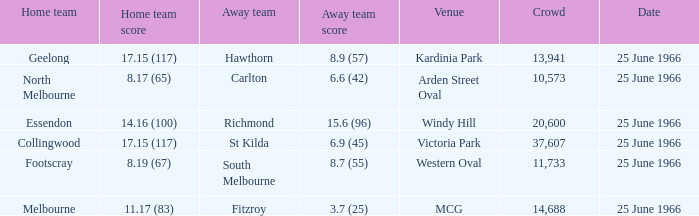What is the total crowd size when a home team scored 17.15 (117) versus hawthorn? 13941.0. 